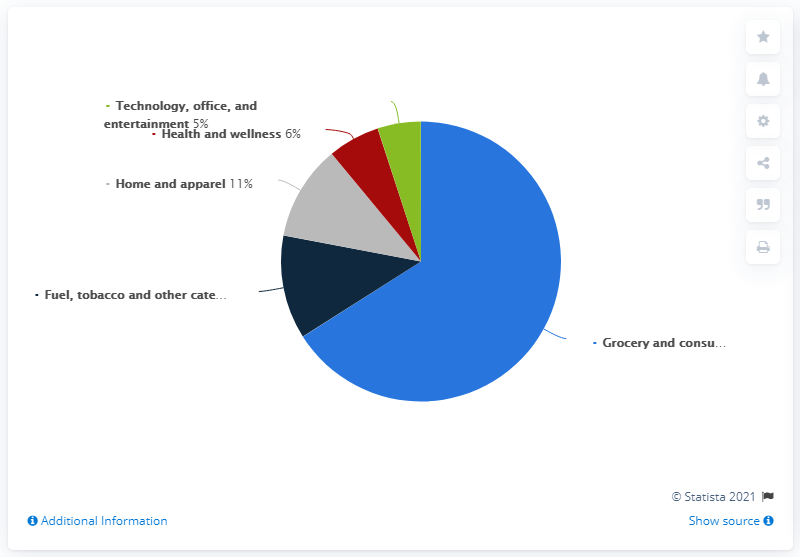Indicate a few pertinent items in this graphic. The request is to add up the three color percentage data, which are labeled as "Green," "Red," and "Grey. Please identify the percentage represented by the green bar. 